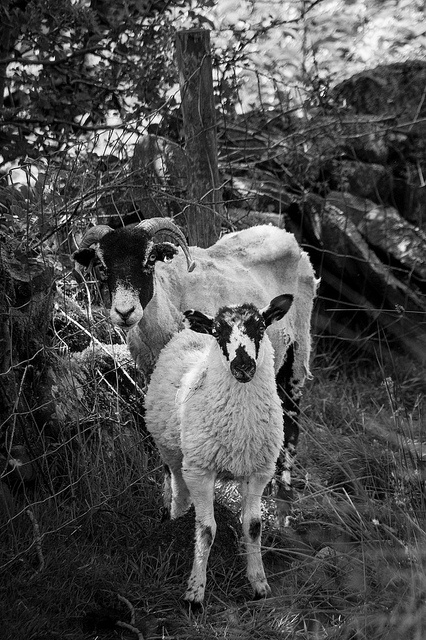Describe the objects in this image and their specific colors. I can see sheep in black, darkgray, gray, and lightgray tones and sheep in black, darkgray, gray, and lightgray tones in this image. 